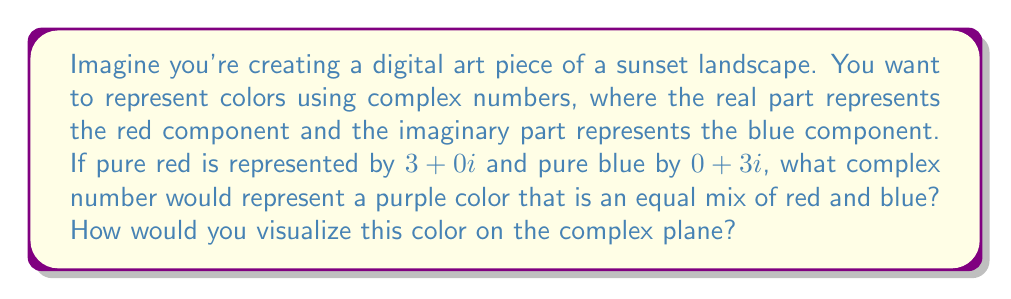What is the answer to this math problem? Let's approach this step-by-step:

1) In this representation, pure red is $3+0i$ and pure blue is $0+3i$.

2) To mix these colors equally, we need to find the average of these two complex numbers:

   $$ \frac{(3+0i) + (0+3i)}{2} $$

3) Simplifying:
   $$ \frac{3+3i}{2} = \frac{3}{2} + \frac{3}{2}i $$

4) This complex number, $\frac{3}{2} + \frac{3}{2}i$, represents the purple color.

5) To visualize this on the complex plane:
   - The real axis represents the red component
   - The imaginary axis represents the blue component
   - The point $(\frac{3}{2}, \frac{3}{2})$ on this plane represents our purple color

[asy]
import graph;
size(200);
xaxis("Red",Arrow);
yaxis("Blue",Arrow);
dot((1.5,1.5),red);
label("Purple $(\frac{3}{2}, \frac{3}{2})$",(1.5,1.5),NE);
draw((0,0)--(1.5,1.5),dashed);
[/asy]

6) The magnitude of this complex number represents the intensity of the color:

   $$ |z| = \sqrt{(\frac{3}{2})^2 + (\frac{3}{2})^2} = \frac{3\sqrt{2}}{2} \approx 2.12 $$

   This is less than 3 (the magnitude of pure red or blue) because mixing colors typically results in a less intense color.

7) The argument of the complex number represents the hue of the color:

   $$ \arg(z) = \tan^{-1}(\frac{3/2}{3/2}) = 45° $$

   This 45° angle indicates an equal mix of red and blue, confirming our purple color.
Answer: The complex number representing an equal mix of red and blue (purple) is $\frac{3}{2} + \frac{3}{2}i$. On the complex plane, this is visualized as the point $(\frac{3}{2}, \frac{3}{2})$, equidistant from the pure red $(3,0)$ and pure blue $(0,3)$ points. 